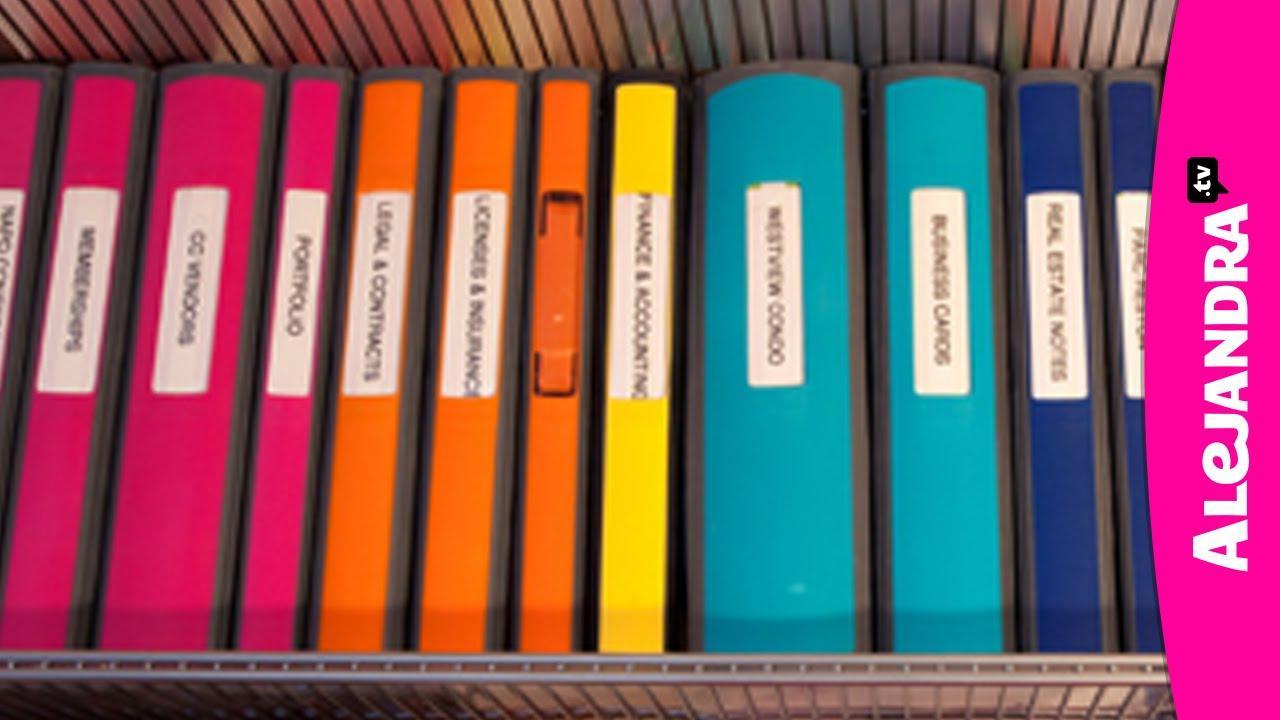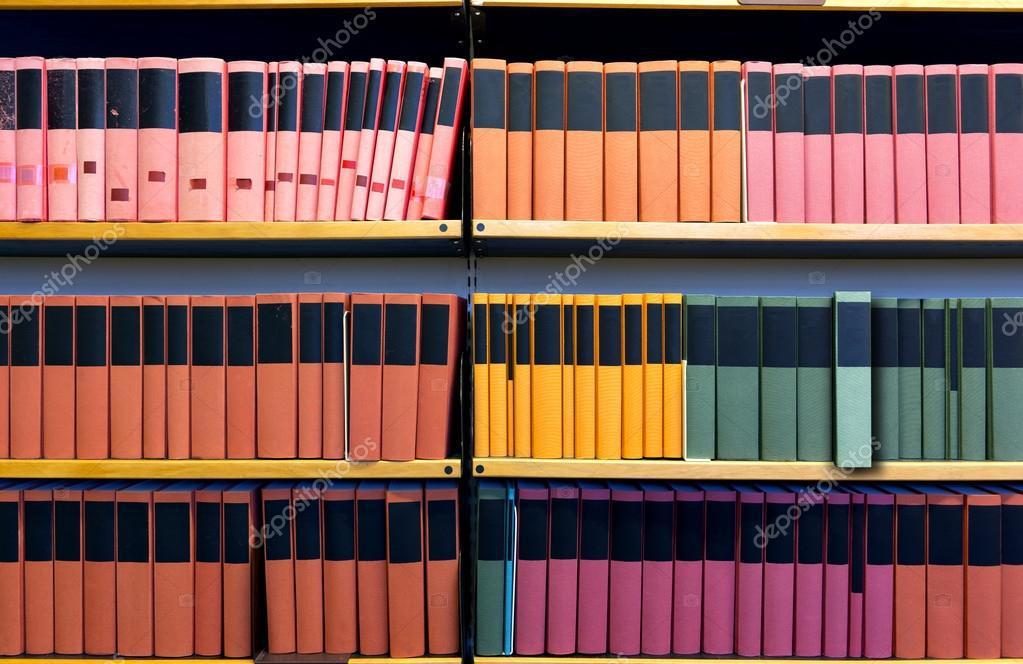The first image is the image on the left, the second image is the image on the right. Evaluate the accuracy of this statement regarding the images: "There are shelves in the image on the right". Is it true? Answer yes or no. Yes. The first image is the image on the left, the second image is the image on the right. Assess this claim about the two images: "At least one image shows a single row of colored binders with white rectangular labels.". Correct or not? Answer yes or no. Yes. 